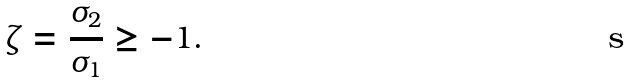Convert formula to latex. <formula><loc_0><loc_0><loc_500><loc_500>\zeta = \frac { \sigma _ { 2 } } { \sigma _ { 1 } } \geq - 1 .</formula> 